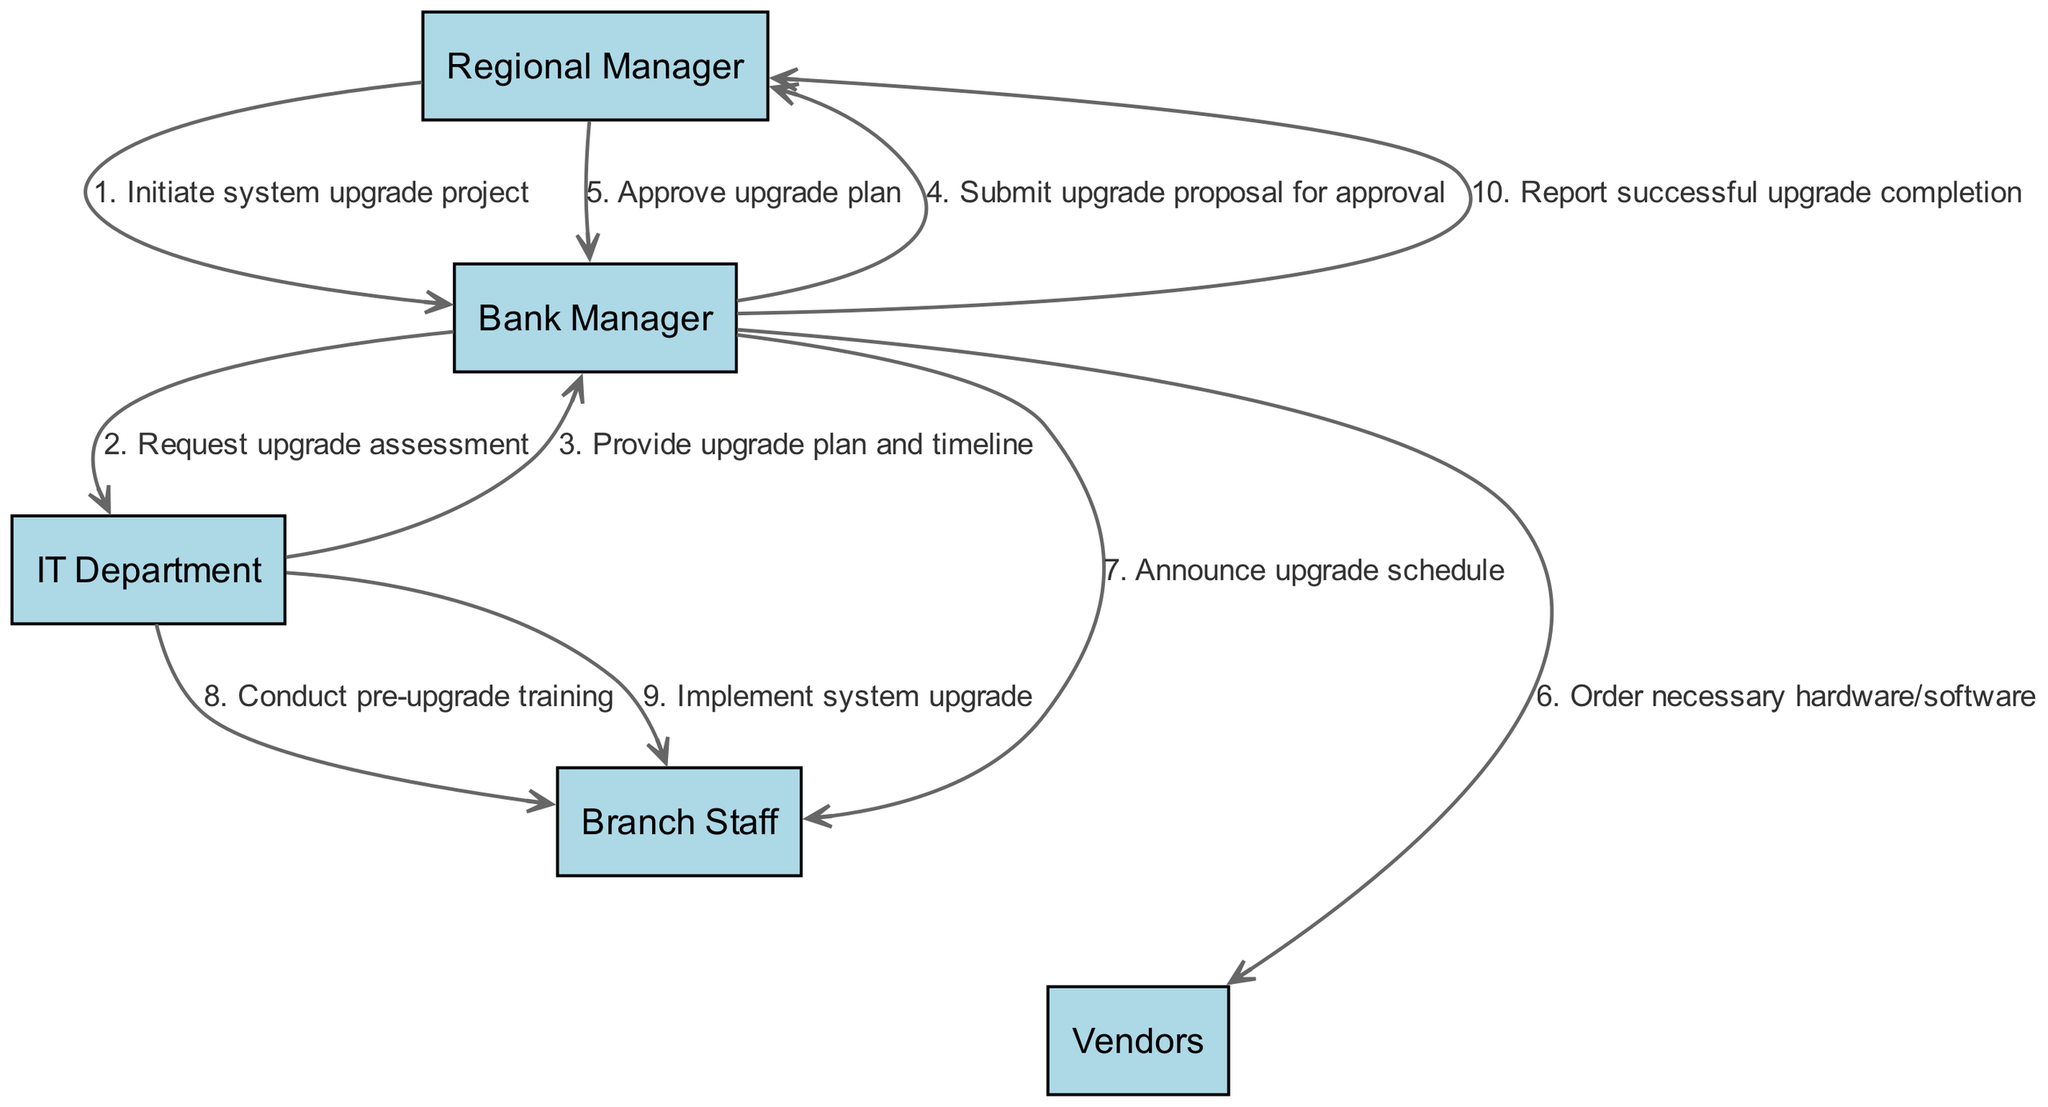What is the first action in the sequence? The first action is initiated by the Regional Manager, who starts the process by sending a message to the Bank Manager to initiate the system upgrade project.
Answer: Initiate system upgrade project How many actors are involved in the diagram? The diagram includes five actors: Regional Manager, Bank Manager, IT Department, Branch Staff, and Vendors. This count is determined by listing each unique actor present in the diagram.
Answer: Five What message does the Bank Manager send to the IT Department? The Bank Manager requests an upgrade assessment from the IT Department as the next step after receiving the initiation message from the Regional Manager.
Answer: Request upgrade assessment Who is responsible for conducting pre-upgrade training? The IT Department is responsible for conducting the pre-upgrade training, as shown in the sequence where they send a message to the Branch Staff specifically for this purpose.
Answer: IT Department What is the final action reported to the Regional Manager? The final action reported to the Regional Manager is the completion of the system upgrade, following the previous steps of implementation and training that had to be executed beforehand.
Answer: Report successful upgrade completion What is the fourth action in the sequence? The fourth action is the Bank Manager submitting the upgrade proposal for approval to the Regional Manager, as the sequence clearly indicates this step.
Answer: Submit upgrade proposal for approval Who does the Bank Manager order hardware/software from? The Bank Manager orders necessary hardware and software from the Vendors after receiving the approval from the Regional Manager for the upgrade plan.
Answer: Vendors What step follows the implementation of the system upgrade? After the implementation of the system upgrade, the next step is the Bank Manager reporting the successful completion of the upgrade to the Regional Manager.
Answer: Report successful upgrade completion What is the relationship between the Regional Manager and the Bank Manager in this sequence? The relationship between the Regional Manager and the Bank Manager is that of a supervisor to a subordinate, with the Regional Manager initiating the project and later approving the upgrade plan after the Bank Manager submits the proposal.
Answer: Supervisor-subordinate 